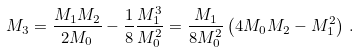Convert formula to latex. <formula><loc_0><loc_0><loc_500><loc_500>M _ { 3 } = \frac { M _ { 1 } M _ { 2 } } { 2 M _ { 0 } } - \frac { 1 } { 8 } \frac { M _ { 1 } ^ { 3 } } { M _ { 0 } ^ { 2 } } = \frac { M _ { 1 } } { 8 M _ { 0 } ^ { 2 } } \left ( 4 M _ { 0 } M _ { 2 } - M _ { 1 } ^ { 2 } \right ) \, .</formula> 